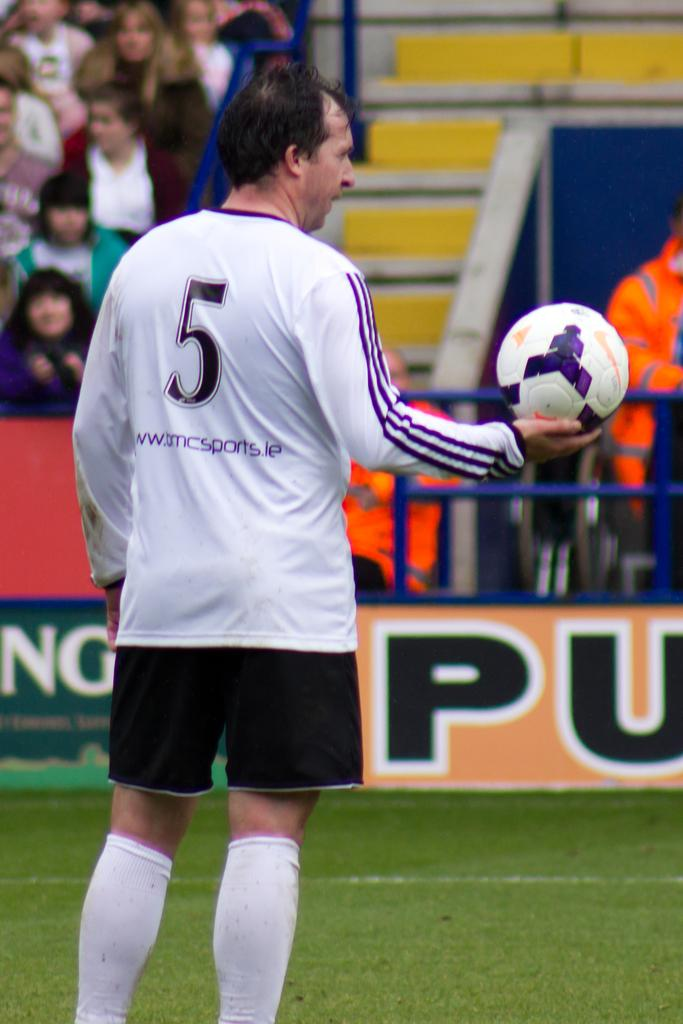<image>
Create a compact narrative representing the image presented. a person with the number 5 on the back of their jersey 